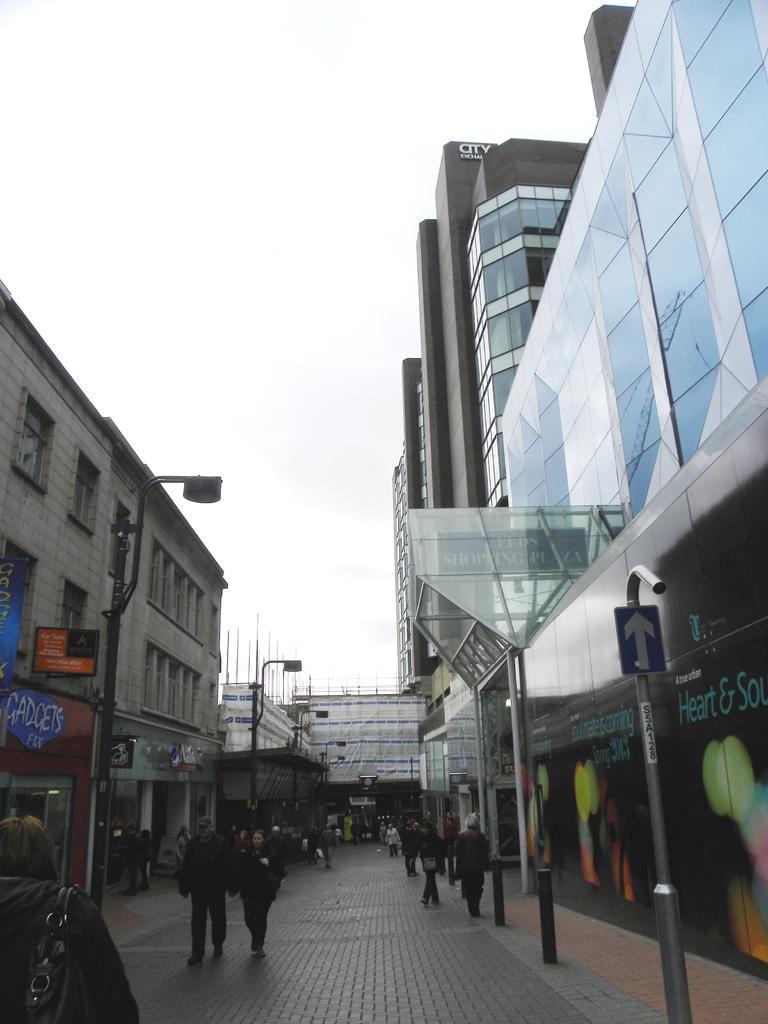Can you describe this image briefly? In this image we can see a few buildings, there are some people, boards, lights, poles and in the background, we can see the sky. 